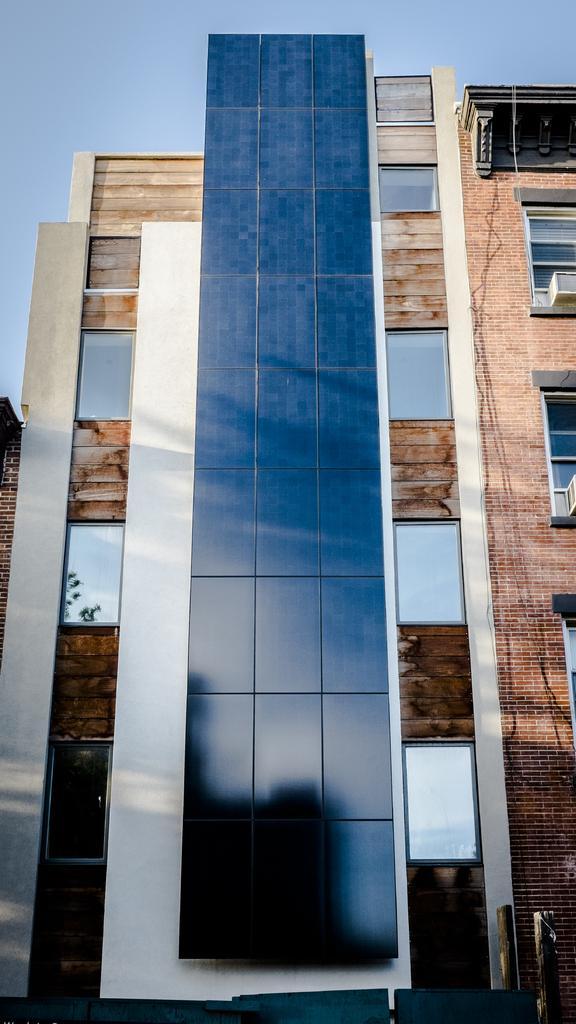How would you summarize this image in a sentence or two? This image is taken outdoors. At the top of the image there is a sky. In the middle of the image there is a building with walls, windows, glasses and roof. 